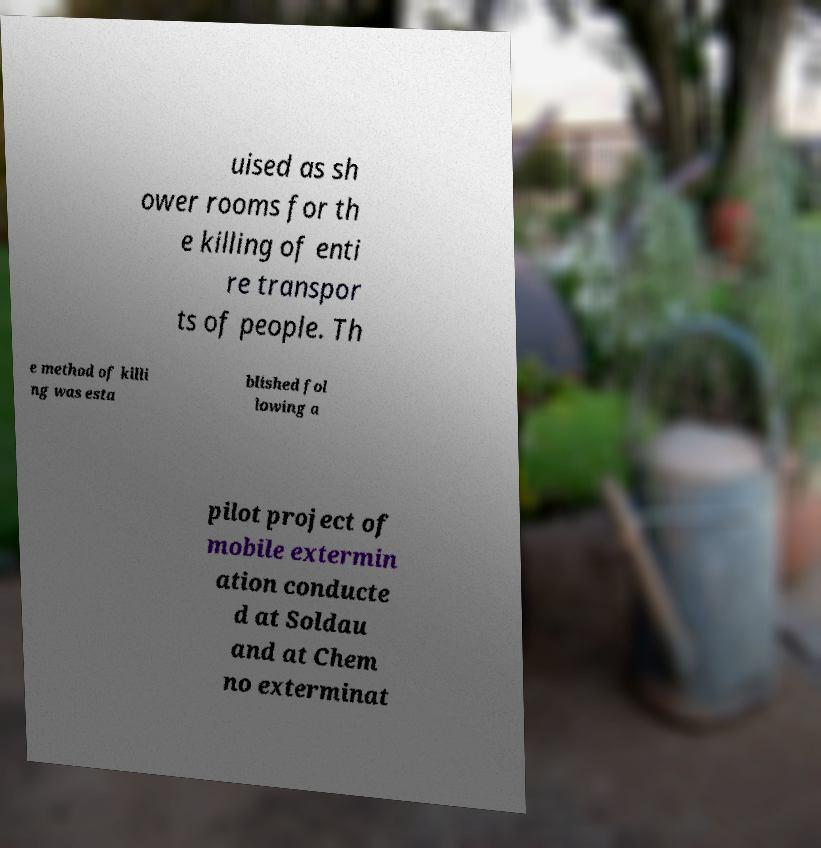Could you assist in decoding the text presented in this image and type it out clearly? uised as sh ower rooms for th e killing of enti re transpor ts of people. Th e method of killi ng was esta blished fol lowing a pilot project of mobile extermin ation conducte d at Soldau and at Chem no exterminat 